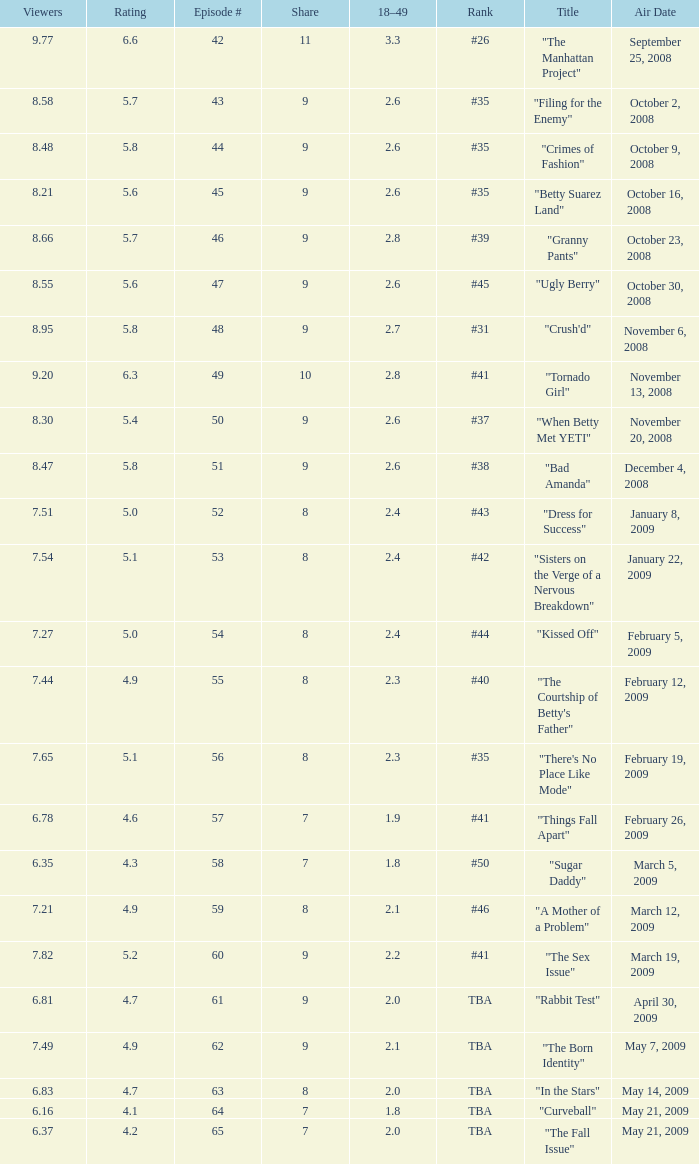What is the Air Date that has a 18–49 larger than 1.9, less than 7.54 viewers and a rating less than 4.9? April 30, 2009, May 14, 2009, May 21, 2009. 